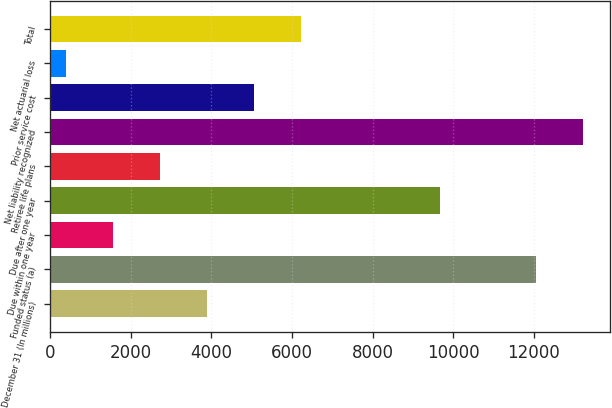Convert chart to OTSL. <chart><loc_0><loc_0><loc_500><loc_500><bar_chart><fcel>December 31 (In millions)<fcel>Funded status (a)<fcel>Due within one year<fcel>Due after one year<fcel>Retiree life plans<fcel>Net liability recognized<fcel>Prior service cost<fcel>Net actuarial loss<fcel>Total<nl><fcel>3896.3<fcel>12052<fcel>1566.1<fcel>9684<fcel>2731.2<fcel>13217.1<fcel>5061.4<fcel>401<fcel>6226.5<nl></chart> 